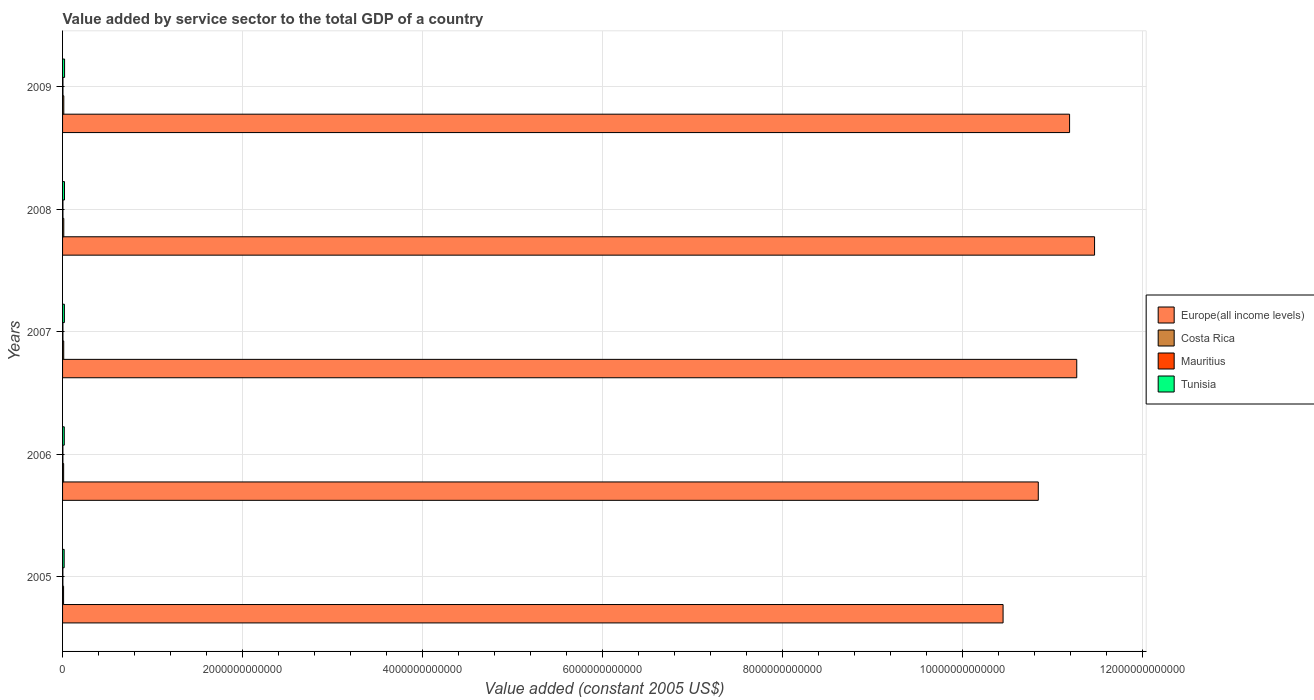How many different coloured bars are there?
Your response must be concise. 4. How many groups of bars are there?
Keep it short and to the point. 5. Are the number of bars per tick equal to the number of legend labels?
Your response must be concise. Yes. Are the number of bars on each tick of the Y-axis equal?
Offer a very short reply. Yes. How many bars are there on the 5th tick from the top?
Your answer should be compact. 4. In how many cases, is the number of bars for a given year not equal to the number of legend labels?
Give a very brief answer. 0. What is the value added by service sector in Tunisia in 2008?
Offer a terse response. 2.15e+1. Across all years, what is the maximum value added by service sector in Mauritius?
Provide a short and direct response. 4.46e+09. Across all years, what is the minimum value added by service sector in Mauritius?
Provide a short and direct response. 3.65e+09. What is the total value added by service sector in Mauritius in the graph?
Offer a very short reply. 2.04e+1. What is the difference between the value added by service sector in Tunisia in 2006 and that in 2009?
Offer a very short reply. -3.24e+09. What is the difference between the value added by service sector in Europe(all income levels) in 2009 and the value added by service sector in Costa Rica in 2007?
Offer a very short reply. 1.12e+13. What is the average value added by service sector in Tunisia per year?
Your response must be concise. 2.02e+1. In the year 2006, what is the difference between the value added by service sector in Europe(all income levels) and value added by service sector in Tunisia?
Ensure brevity in your answer.  1.08e+13. What is the ratio of the value added by service sector in Europe(all income levels) in 2007 to that in 2008?
Your answer should be very brief. 0.98. Is the value added by service sector in Europe(all income levels) in 2006 less than that in 2009?
Your response must be concise. Yes. Is the difference between the value added by service sector in Europe(all income levels) in 2005 and 2006 greater than the difference between the value added by service sector in Tunisia in 2005 and 2006?
Keep it short and to the point. No. What is the difference between the highest and the second highest value added by service sector in Tunisia?
Offer a terse response. 7.92e+08. What is the difference between the highest and the lowest value added by service sector in Costa Rica?
Keep it short and to the point. 2.53e+09. What does the 4th bar from the top in 2005 represents?
Ensure brevity in your answer.  Europe(all income levels). What does the 4th bar from the bottom in 2005 represents?
Provide a short and direct response. Tunisia. Is it the case that in every year, the sum of the value added by service sector in Europe(all income levels) and value added by service sector in Mauritius is greater than the value added by service sector in Costa Rica?
Provide a succinct answer. Yes. How many bars are there?
Your answer should be very brief. 20. Are all the bars in the graph horizontal?
Ensure brevity in your answer.  Yes. What is the difference between two consecutive major ticks on the X-axis?
Provide a succinct answer. 2.00e+12. Are the values on the major ticks of X-axis written in scientific E-notation?
Give a very brief answer. No. How many legend labels are there?
Offer a very short reply. 4. How are the legend labels stacked?
Offer a very short reply. Vertical. What is the title of the graph?
Provide a short and direct response. Value added by service sector to the total GDP of a country. Does "Ireland" appear as one of the legend labels in the graph?
Keep it short and to the point. No. What is the label or title of the X-axis?
Offer a very short reply. Value added (constant 2005 US$). What is the label or title of the Y-axis?
Give a very brief answer. Years. What is the Value added (constant 2005 US$) in Europe(all income levels) in 2005?
Your response must be concise. 1.05e+13. What is the Value added (constant 2005 US$) of Costa Rica in 2005?
Offer a very short reply. 1.12e+1. What is the Value added (constant 2005 US$) in Mauritius in 2005?
Your answer should be compact. 3.65e+09. What is the Value added (constant 2005 US$) of Tunisia in 2005?
Your answer should be very brief. 1.78e+1. What is the Value added (constant 2005 US$) of Europe(all income levels) in 2006?
Give a very brief answer. 1.08e+13. What is the Value added (constant 2005 US$) in Costa Rica in 2006?
Give a very brief answer. 1.19e+1. What is the Value added (constant 2005 US$) of Mauritius in 2006?
Give a very brief answer. 3.86e+09. What is the Value added (constant 2005 US$) of Tunisia in 2006?
Your response must be concise. 1.91e+1. What is the Value added (constant 2005 US$) in Europe(all income levels) in 2007?
Provide a short and direct response. 1.13e+13. What is the Value added (constant 2005 US$) of Costa Rica in 2007?
Make the answer very short. 1.28e+1. What is the Value added (constant 2005 US$) of Mauritius in 2007?
Provide a succinct answer. 4.11e+09. What is the Value added (constant 2005 US$) in Tunisia in 2007?
Provide a short and direct response. 2.02e+1. What is the Value added (constant 2005 US$) of Europe(all income levels) in 2008?
Provide a short and direct response. 1.15e+13. What is the Value added (constant 2005 US$) of Costa Rica in 2008?
Provide a succinct answer. 1.35e+1. What is the Value added (constant 2005 US$) in Mauritius in 2008?
Make the answer very short. 4.35e+09. What is the Value added (constant 2005 US$) in Tunisia in 2008?
Provide a short and direct response. 2.15e+1. What is the Value added (constant 2005 US$) of Europe(all income levels) in 2009?
Offer a terse response. 1.12e+13. What is the Value added (constant 2005 US$) of Costa Rica in 2009?
Your answer should be very brief. 1.37e+1. What is the Value added (constant 2005 US$) of Mauritius in 2009?
Provide a succinct answer. 4.46e+09. What is the Value added (constant 2005 US$) of Tunisia in 2009?
Your answer should be very brief. 2.23e+1. Across all years, what is the maximum Value added (constant 2005 US$) of Europe(all income levels)?
Provide a succinct answer. 1.15e+13. Across all years, what is the maximum Value added (constant 2005 US$) in Costa Rica?
Ensure brevity in your answer.  1.37e+1. Across all years, what is the maximum Value added (constant 2005 US$) of Mauritius?
Provide a short and direct response. 4.46e+09. Across all years, what is the maximum Value added (constant 2005 US$) of Tunisia?
Keep it short and to the point. 2.23e+1. Across all years, what is the minimum Value added (constant 2005 US$) of Europe(all income levels)?
Your response must be concise. 1.05e+13. Across all years, what is the minimum Value added (constant 2005 US$) of Costa Rica?
Provide a short and direct response. 1.12e+1. Across all years, what is the minimum Value added (constant 2005 US$) in Mauritius?
Your response must be concise. 3.65e+09. Across all years, what is the minimum Value added (constant 2005 US$) in Tunisia?
Your answer should be compact. 1.78e+1. What is the total Value added (constant 2005 US$) in Europe(all income levels) in the graph?
Provide a short and direct response. 5.52e+13. What is the total Value added (constant 2005 US$) in Costa Rica in the graph?
Provide a succinct answer. 6.31e+1. What is the total Value added (constant 2005 US$) in Mauritius in the graph?
Make the answer very short. 2.04e+1. What is the total Value added (constant 2005 US$) in Tunisia in the graph?
Your answer should be compact. 1.01e+11. What is the difference between the Value added (constant 2005 US$) of Europe(all income levels) in 2005 and that in 2006?
Offer a terse response. -3.91e+11. What is the difference between the Value added (constant 2005 US$) in Costa Rica in 2005 and that in 2006?
Your response must be concise. -7.75e+08. What is the difference between the Value added (constant 2005 US$) in Mauritius in 2005 and that in 2006?
Your answer should be compact. -2.06e+08. What is the difference between the Value added (constant 2005 US$) of Tunisia in 2005 and that in 2006?
Offer a very short reply. -1.29e+09. What is the difference between the Value added (constant 2005 US$) of Europe(all income levels) in 2005 and that in 2007?
Ensure brevity in your answer.  -8.19e+11. What is the difference between the Value added (constant 2005 US$) of Costa Rica in 2005 and that in 2007?
Your answer should be compact. -1.64e+09. What is the difference between the Value added (constant 2005 US$) in Mauritius in 2005 and that in 2007?
Your response must be concise. -4.61e+08. What is the difference between the Value added (constant 2005 US$) of Tunisia in 2005 and that in 2007?
Your answer should be compact. -2.45e+09. What is the difference between the Value added (constant 2005 US$) in Europe(all income levels) in 2005 and that in 2008?
Your answer should be very brief. -1.02e+12. What is the difference between the Value added (constant 2005 US$) of Costa Rica in 2005 and that in 2008?
Give a very brief answer. -2.38e+09. What is the difference between the Value added (constant 2005 US$) of Mauritius in 2005 and that in 2008?
Provide a short and direct response. -6.96e+08. What is the difference between the Value added (constant 2005 US$) of Tunisia in 2005 and that in 2008?
Your answer should be compact. -3.74e+09. What is the difference between the Value added (constant 2005 US$) of Europe(all income levels) in 2005 and that in 2009?
Your response must be concise. -7.39e+11. What is the difference between the Value added (constant 2005 US$) in Costa Rica in 2005 and that in 2009?
Your answer should be compact. -2.53e+09. What is the difference between the Value added (constant 2005 US$) of Mauritius in 2005 and that in 2009?
Provide a short and direct response. -8.15e+08. What is the difference between the Value added (constant 2005 US$) in Tunisia in 2005 and that in 2009?
Your response must be concise. -4.53e+09. What is the difference between the Value added (constant 2005 US$) in Europe(all income levels) in 2006 and that in 2007?
Keep it short and to the point. -4.27e+11. What is the difference between the Value added (constant 2005 US$) in Costa Rica in 2006 and that in 2007?
Keep it short and to the point. -8.64e+08. What is the difference between the Value added (constant 2005 US$) of Mauritius in 2006 and that in 2007?
Make the answer very short. -2.55e+08. What is the difference between the Value added (constant 2005 US$) of Tunisia in 2006 and that in 2007?
Ensure brevity in your answer.  -1.15e+09. What is the difference between the Value added (constant 2005 US$) of Europe(all income levels) in 2006 and that in 2008?
Provide a short and direct response. -6.25e+11. What is the difference between the Value added (constant 2005 US$) in Costa Rica in 2006 and that in 2008?
Offer a terse response. -1.60e+09. What is the difference between the Value added (constant 2005 US$) of Mauritius in 2006 and that in 2008?
Your answer should be very brief. -4.90e+08. What is the difference between the Value added (constant 2005 US$) in Tunisia in 2006 and that in 2008?
Keep it short and to the point. -2.45e+09. What is the difference between the Value added (constant 2005 US$) in Europe(all income levels) in 2006 and that in 2009?
Provide a succinct answer. -3.48e+11. What is the difference between the Value added (constant 2005 US$) in Costa Rica in 2006 and that in 2009?
Your response must be concise. -1.76e+09. What is the difference between the Value added (constant 2005 US$) of Mauritius in 2006 and that in 2009?
Your answer should be compact. -6.08e+08. What is the difference between the Value added (constant 2005 US$) of Tunisia in 2006 and that in 2009?
Your answer should be compact. -3.24e+09. What is the difference between the Value added (constant 2005 US$) in Europe(all income levels) in 2007 and that in 2008?
Offer a very short reply. -1.98e+11. What is the difference between the Value added (constant 2005 US$) of Costa Rica in 2007 and that in 2008?
Ensure brevity in your answer.  -7.38e+08. What is the difference between the Value added (constant 2005 US$) of Mauritius in 2007 and that in 2008?
Offer a very short reply. -2.35e+08. What is the difference between the Value added (constant 2005 US$) in Tunisia in 2007 and that in 2008?
Provide a short and direct response. -1.29e+09. What is the difference between the Value added (constant 2005 US$) of Europe(all income levels) in 2007 and that in 2009?
Keep it short and to the point. 7.96e+1. What is the difference between the Value added (constant 2005 US$) of Costa Rica in 2007 and that in 2009?
Offer a very short reply. -8.92e+08. What is the difference between the Value added (constant 2005 US$) of Mauritius in 2007 and that in 2009?
Keep it short and to the point. -3.53e+08. What is the difference between the Value added (constant 2005 US$) in Tunisia in 2007 and that in 2009?
Give a very brief answer. -2.09e+09. What is the difference between the Value added (constant 2005 US$) of Europe(all income levels) in 2008 and that in 2009?
Your answer should be compact. 2.78e+11. What is the difference between the Value added (constant 2005 US$) in Costa Rica in 2008 and that in 2009?
Offer a terse response. -1.53e+08. What is the difference between the Value added (constant 2005 US$) of Mauritius in 2008 and that in 2009?
Keep it short and to the point. -1.18e+08. What is the difference between the Value added (constant 2005 US$) of Tunisia in 2008 and that in 2009?
Your response must be concise. -7.92e+08. What is the difference between the Value added (constant 2005 US$) in Europe(all income levels) in 2005 and the Value added (constant 2005 US$) in Costa Rica in 2006?
Make the answer very short. 1.04e+13. What is the difference between the Value added (constant 2005 US$) of Europe(all income levels) in 2005 and the Value added (constant 2005 US$) of Mauritius in 2006?
Offer a terse response. 1.04e+13. What is the difference between the Value added (constant 2005 US$) of Europe(all income levels) in 2005 and the Value added (constant 2005 US$) of Tunisia in 2006?
Keep it short and to the point. 1.04e+13. What is the difference between the Value added (constant 2005 US$) in Costa Rica in 2005 and the Value added (constant 2005 US$) in Mauritius in 2006?
Your answer should be compact. 7.31e+09. What is the difference between the Value added (constant 2005 US$) of Costa Rica in 2005 and the Value added (constant 2005 US$) of Tunisia in 2006?
Provide a short and direct response. -7.89e+09. What is the difference between the Value added (constant 2005 US$) in Mauritius in 2005 and the Value added (constant 2005 US$) in Tunisia in 2006?
Your response must be concise. -1.54e+1. What is the difference between the Value added (constant 2005 US$) of Europe(all income levels) in 2005 and the Value added (constant 2005 US$) of Costa Rica in 2007?
Make the answer very short. 1.04e+13. What is the difference between the Value added (constant 2005 US$) in Europe(all income levels) in 2005 and the Value added (constant 2005 US$) in Mauritius in 2007?
Your answer should be very brief. 1.04e+13. What is the difference between the Value added (constant 2005 US$) in Europe(all income levels) in 2005 and the Value added (constant 2005 US$) in Tunisia in 2007?
Keep it short and to the point. 1.04e+13. What is the difference between the Value added (constant 2005 US$) of Costa Rica in 2005 and the Value added (constant 2005 US$) of Mauritius in 2007?
Your answer should be very brief. 7.05e+09. What is the difference between the Value added (constant 2005 US$) of Costa Rica in 2005 and the Value added (constant 2005 US$) of Tunisia in 2007?
Offer a very short reply. -9.04e+09. What is the difference between the Value added (constant 2005 US$) in Mauritius in 2005 and the Value added (constant 2005 US$) in Tunisia in 2007?
Your response must be concise. -1.66e+1. What is the difference between the Value added (constant 2005 US$) in Europe(all income levels) in 2005 and the Value added (constant 2005 US$) in Costa Rica in 2008?
Your response must be concise. 1.04e+13. What is the difference between the Value added (constant 2005 US$) in Europe(all income levels) in 2005 and the Value added (constant 2005 US$) in Mauritius in 2008?
Provide a short and direct response. 1.04e+13. What is the difference between the Value added (constant 2005 US$) in Europe(all income levels) in 2005 and the Value added (constant 2005 US$) in Tunisia in 2008?
Offer a terse response. 1.04e+13. What is the difference between the Value added (constant 2005 US$) of Costa Rica in 2005 and the Value added (constant 2005 US$) of Mauritius in 2008?
Keep it short and to the point. 6.82e+09. What is the difference between the Value added (constant 2005 US$) in Costa Rica in 2005 and the Value added (constant 2005 US$) in Tunisia in 2008?
Your response must be concise. -1.03e+1. What is the difference between the Value added (constant 2005 US$) in Mauritius in 2005 and the Value added (constant 2005 US$) in Tunisia in 2008?
Provide a succinct answer. -1.79e+1. What is the difference between the Value added (constant 2005 US$) of Europe(all income levels) in 2005 and the Value added (constant 2005 US$) of Costa Rica in 2009?
Provide a succinct answer. 1.04e+13. What is the difference between the Value added (constant 2005 US$) of Europe(all income levels) in 2005 and the Value added (constant 2005 US$) of Mauritius in 2009?
Provide a succinct answer. 1.04e+13. What is the difference between the Value added (constant 2005 US$) of Europe(all income levels) in 2005 and the Value added (constant 2005 US$) of Tunisia in 2009?
Offer a very short reply. 1.04e+13. What is the difference between the Value added (constant 2005 US$) in Costa Rica in 2005 and the Value added (constant 2005 US$) in Mauritius in 2009?
Give a very brief answer. 6.70e+09. What is the difference between the Value added (constant 2005 US$) in Costa Rica in 2005 and the Value added (constant 2005 US$) in Tunisia in 2009?
Your answer should be compact. -1.11e+1. What is the difference between the Value added (constant 2005 US$) in Mauritius in 2005 and the Value added (constant 2005 US$) in Tunisia in 2009?
Give a very brief answer. -1.86e+1. What is the difference between the Value added (constant 2005 US$) in Europe(all income levels) in 2006 and the Value added (constant 2005 US$) in Costa Rica in 2007?
Offer a very short reply. 1.08e+13. What is the difference between the Value added (constant 2005 US$) of Europe(all income levels) in 2006 and the Value added (constant 2005 US$) of Mauritius in 2007?
Ensure brevity in your answer.  1.08e+13. What is the difference between the Value added (constant 2005 US$) in Europe(all income levels) in 2006 and the Value added (constant 2005 US$) in Tunisia in 2007?
Offer a terse response. 1.08e+13. What is the difference between the Value added (constant 2005 US$) of Costa Rica in 2006 and the Value added (constant 2005 US$) of Mauritius in 2007?
Provide a short and direct response. 7.83e+09. What is the difference between the Value added (constant 2005 US$) in Costa Rica in 2006 and the Value added (constant 2005 US$) in Tunisia in 2007?
Your answer should be very brief. -8.27e+09. What is the difference between the Value added (constant 2005 US$) of Mauritius in 2006 and the Value added (constant 2005 US$) of Tunisia in 2007?
Provide a short and direct response. -1.64e+1. What is the difference between the Value added (constant 2005 US$) in Europe(all income levels) in 2006 and the Value added (constant 2005 US$) in Costa Rica in 2008?
Your response must be concise. 1.08e+13. What is the difference between the Value added (constant 2005 US$) in Europe(all income levels) in 2006 and the Value added (constant 2005 US$) in Mauritius in 2008?
Keep it short and to the point. 1.08e+13. What is the difference between the Value added (constant 2005 US$) in Europe(all income levels) in 2006 and the Value added (constant 2005 US$) in Tunisia in 2008?
Provide a succinct answer. 1.08e+13. What is the difference between the Value added (constant 2005 US$) in Costa Rica in 2006 and the Value added (constant 2005 US$) in Mauritius in 2008?
Provide a succinct answer. 7.59e+09. What is the difference between the Value added (constant 2005 US$) in Costa Rica in 2006 and the Value added (constant 2005 US$) in Tunisia in 2008?
Give a very brief answer. -9.56e+09. What is the difference between the Value added (constant 2005 US$) in Mauritius in 2006 and the Value added (constant 2005 US$) in Tunisia in 2008?
Your answer should be compact. -1.76e+1. What is the difference between the Value added (constant 2005 US$) of Europe(all income levels) in 2006 and the Value added (constant 2005 US$) of Costa Rica in 2009?
Ensure brevity in your answer.  1.08e+13. What is the difference between the Value added (constant 2005 US$) in Europe(all income levels) in 2006 and the Value added (constant 2005 US$) in Mauritius in 2009?
Make the answer very short. 1.08e+13. What is the difference between the Value added (constant 2005 US$) in Europe(all income levels) in 2006 and the Value added (constant 2005 US$) in Tunisia in 2009?
Provide a short and direct response. 1.08e+13. What is the difference between the Value added (constant 2005 US$) of Costa Rica in 2006 and the Value added (constant 2005 US$) of Mauritius in 2009?
Provide a short and direct response. 7.48e+09. What is the difference between the Value added (constant 2005 US$) of Costa Rica in 2006 and the Value added (constant 2005 US$) of Tunisia in 2009?
Ensure brevity in your answer.  -1.04e+1. What is the difference between the Value added (constant 2005 US$) of Mauritius in 2006 and the Value added (constant 2005 US$) of Tunisia in 2009?
Your answer should be compact. -1.84e+1. What is the difference between the Value added (constant 2005 US$) of Europe(all income levels) in 2007 and the Value added (constant 2005 US$) of Costa Rica in 2008?
Provide a short and direct response. 1.13e+13. What is the difference between the Value added (constant 2005 US$) of Europe(all income levels) in 2007 and the Value added (constant 2005 US$) of Mauritius in 2008?
Your answer should be compact. 1.13e+13. What is the difference between the Value added (constant 2005 US$) of Europe(all income levels) in 2007 and the Value added (constant 2005 US$) of Tunisia in 2008?
Offer a terse response. 1.12e+13. What is the difference between the Value added (constant 2005 US$) of Costa Rica in 2007 and the Value added (constant 2005 US$) of Mauritius in 2008?
Make the answer very short. 8.46e+09. What is the difference between the Value added (constant 2005 US$) in Costa Rica in 2007 and the Value added (constant 2005 US$) in Tunisia in 2008?
Give a very brief answer. -8.70e+09. What is the difference between the Value added (constant 2005 US$) of Mauritius in 2007 and the Value added (constant 2005 US$) of Tunisia in 2008?
Offer a very short reply. -1.74e+1. What is the difference between the Value added (constant 2005 US$) in Europe(all income levels) in 2007 and the Value added (constant 2005 US$) in Costa Rica in 2009?
Ensure brevity in your answer.  1.13e+13. What is the difference between the Value added (constant 2005 US$) of Europe(all income levels) in 2007 and the Value added (constant 2005 US$) of Mauritius in 2009?
Make the answer very short. 1.13e+13. What is the difference between the Value added (constant 2005 US$) of Europe(all income levels) in 2007 and the Value added (constant 2005 US$) of Tunisia in 2009?
Keep it short and to the point. 1.12e+13. What is the difference between the Value added (constant 2005 US$) of Costa Rica in 2007 and the Value added (constant 2005 US$) of Mauritius in 2009?
Provide a short and direct response. 8.34e+09. What is the difference between the Value added (constant 2005 US$) in Costa Rica in 2007 and the Value added (constant 2005 US$) in Tunisia in 2009?
Make the answer very short. -9.49e+09. What is the difference between the Value added (constant 2005 US$) in Mauritius in 2007 and the Value added (constant 2005 US$) in Tunisia in 2009?
Give a very brief answer. -1.82e+1. What is the difference between the Value added (constant 2005 US$) in Europe(all income levels) in 2008 and the Value added (constant 2005 US$) in Costa Rica in 2009?
Your response must be concise. 1.15e+13. What is the difference between the Value added (constant 2005 US$) of Europe(all income levels) in 2008 and the Value added (constant 2005 US$) of Mauritius in 2009?
Offer a terse response. 1.15e+13. What is the difference between the Value added (constant 2005 US$) in Europe(all income levels) in 2008 and the Value added (constant 2005 US$) in Tunisia in 2009?
Your answer should be compact. 1.14e+13. What is the difference between the Value added (constant 2005 US$) of Costa Rica in 2008 and the Value added (constant 2005 US$) of Mauritius in 2009?
Your answer should be very brief. 9.08e+09. What is the difference between the Value added (constant 2005 US$) of Costa Rica in 2008 and the Value added (constant 2005 US$) of Tunisia in 2009?
Your answer should be compact. -8.75e+09. What is the difference between the Value added (constant 2005 US$) in Mauritius in 2008 and the Value added (constant 2005 US$) in Tunisia in 2009?
Your answer should be compact. -1.79e+1. What is the average Value added (constant 2005 US$) in Europe(all income levels) per year?
Keep it short and to the point. 1.10e+13. What is the average Value added (constant 2005 US$) of Costa Rica per year?
Provide a short and direct response. 1.26e+1. What is the average Value added (constant 2005 US$) of Mauritius per year?
Offer a very short reply. 4.09e+09. What is the average Value added (constant 2005 US$) in Tunisia per year?
Provide a short and direct response. 2.02e+1. In the year 2005, what is the difference between the Value added (constant 2005 US$) in Europe(all income levels) and Value added (constant 2005 US$) in Costa Rica?
Keep it short and to the point. 1.04e+13. In the year 2005, what is the difference between the Value added (constant 2005 US$) of Europe(all income levels) and Value added (constant 2005 US$) of Mauritius?
Ensure brevity in your answer.  1.04e+13. In the year 2005, what is the difference between the Value added (constant 2005 US$) of Europe(all income levels) and Value added (constant 2005 US$) of Tunisia?
Your response must be concise. 1.04e+13. In the year 2005, what is the difference between the Value added (constant 2005 US$) of Costa Rica and Value added (constant 2005 US$) of Mauritius?
Provide a short and direct response. 7.51e+09. In the year 2005, what is the difference between the Value added (constant 2005 US$) of Costa Rica and Value added (constant 2005 US$) of Tunisia?
Your answer should be compact. -6.60e+09. In the year 2005, what is the difference between the Value added (constant 2005 US$) in Mauritius and Value added (constant 2005 US$) in Tunisia?
Give a very brief answer. -1.41e+1. In the year 2006, what is the difference between the Value added (constant 2005 US$) of Europe(all income levels) and Value added (constant 2005 US$) of Costa Rica?
Provide a succinct answer. 1.08e+13. In the year 2006, what is the difference between the Value added (constant 2005 US$) in Europe(all income levels) and Value added (constant 2005 US$) in Mauritius?
Ensure brevity in your answer.  1.08e+13. In the year 2006, what is the difference between the Value added (constant 2005 US$) of Europe(all income levels) and Value added (constant 2005 US$) of Tunisia?
Make the answer very short. 1.08e+13. In the year 2006, what is the difference between the Value added (constant 2005 US$) of Costa Rica and Value added (constant 2005 US$) of Mauritius?
Offer a very short reply. 8.08e+09. In the year 2006, what is the difference between the Value added (constant 2005 US$) of Costa Rica and Value added (constant 2005 US$) of Tunisia?
Offer a very short reply. -7.11e+09. In the year 2006, what is the difference between the Value added (constant 2005 US$) in Mauritius and Value added (constant 2005 US$) in Tunisia?
Offer a terse response. -1.52e+1. In the year 2007, what is the difference between the Value added (constant 2005 US$) of Europe(all income levels) and Value added (constant 2005 US$) of Costa Rica?
Your response must be concise. 1.13e+13. In the year 2007, what is the difference between the Value added (constant 2005 US$) of Europe(all income levels) and Value added (constant 2005 US$) of Mauritius?
Ensure brevity in your answer.  1.13e+13. In the year 2007, what is the difference between the Value added (constant 2005 US$) in Europe(all income levels) and Value added (constant 2005 US$) in Tunisia?
Your answer should be compact. 1.13e+13. In the year 2007, what is the difference between the Value added (constant 2005 US$) in Costa Rica and Value added (constant 2005 US$) in Mauritius?
Offer a terse response. 8.69e+09. In the year 2007, what is the difference between the Value added (constant 2005 US$) of Costa Rica and Value added (constant 2005 US$) of Tunisia?
Ensure brevity in your answer.  -7.40e+09. In the year 2007, what is the difference between the Value added (constant 2005 US$) of Mauritius and Value added (constant 2005 US$) of Tunisia?
Offer a very short reply. -1.61e+1. In the year 2008, what is the difference between the Value added (constant 2005 US$) of Europe(all income levels) and Value added (constant 2005 US$) of Costa Rica?
Give a very brief answer. 1.15e+13. In the year 2008, what is the difference between the Value added (constant 2005 US$) in Europe(all income levels) and Value added (constant 2005 US$) in Mauritius?
Make the answer very short. 1.15e+13. In the year 2008, what is the difference between the Value added (constant 2005 US$) in Europe(all income levels) and Value added (constant 2005 US$) in Tunisia?
Give a very brief answer. 1.14e+13. In the year 2008, what is the difference between the Value added (constant 2005 US$) in Costa Rica and Value added (constant 2005 US$) in Mauritius?
Keep it short and to the point. 9.20e+09. In the year 2008, what is the difference between the Value added (constant 2005 US$) in Costa Rica and Value added (constant 2005 US$) in Tunisia?
Ensure brevity in your answer.  -7.96e+09. In the year 2008, what is the difference between the Value added (constant 2005 US$) in Mauritius and Value added (constant 2005 US$) in Tunisia?
Ensure brevity in your answer.  -1.72e+1. In the year 2009, what is the difference between the Value added (constant 2005 US$) of Europe(all income levels) and Value added (constant 2005 US$) of Costa Rica?
Keep it short and to the point. 1.12e+13. In the year 2009, what is the difference between the Value added (constant 2005 US$) of Europe(all income levels) and Value added (constant 2005 US$) of Mauritius?
Offer a very short reply. 1.12e+13. In the year 2009, what is the difference between the Value added (constant 2005 US$) in Europe(all income levels) and Value added (constant 2005 US$) in Tunisia?
Give a very brief answer. 1.12e+13. In the year 2009, what is the difference between the Value added (constant 2005 US$) in Costa Rica and Value added (constant 2005 US$) in Mauritius?
Offer a very short reply. 9.23e+09. In the year 2009, what is the difference between the Value added (constant 2005 US$) in Costa Rica and Value added (constant 2005 US$) in Tunisia?
Make the answer very short. -8.60e+09. In the year 2009, what is the difference between the Value added (constant 2005 US$) in Mauritius and Value added (constant 2005 US$) in Tunisia?
Offer a terse response. -1.78e+1. What is the ratio of the Value added (constant 2005 US$) in Europe(all income levels) in 2005 to that in 2006?
Ensure brevity in your answer.  0.96. What is the ratio of the Value added (constant 2005 US$) in Costa Rica in 2005 to that in 2006?
Your response must be concise. 0.94. What is the ratio of the Value added (constant 2005 US$) in Mauritius in 2005 to that in 2006?
Your answer should be compact. 0.95. What is the ratio of the Value added (constant 2005 US$) of Tunisia in 2005 to that in 2006?
Provide a short and direct response. 0.93. What is the ratio of the Value added (constant 2005 US$) of Europe(all income levels) in 2005 to that in 2007?
Provide a succinct answer. 0.93. What is the ratio of the Value added (constant 2005 US$) in Costa Rica in 2005 to that in 2007?
Provide a short and direct response. 0.87. What is the ratio of the Value added (constant 2005 US$) of Mauritius in 2005 to that in 2007?
Give a very brief answer. 0.89. What is the ratio of the Value added (constant 2005 US$) in Tunisia in 2005 to that in 2007?
Provide a succinct answer. 0.88. What is the ratio of the Value added (constant 2005 US$) in Europe(all income levels) in 2005 to that in 2008?
Make the answer very short. 0.91. What is the ratio of the Value added (constant 2005 US$) in Costa Rica in 2005 to that in 2008?
Provide a short and direct response. 0.82. What is the ratio of the Value added (constant 2005 US$) in Mauritius in 2005 to that in 2008?
Ensure brevity in your answer.  0.84. What is the ratio of the Value added (constant 2005 US$) in Tunisia in 2005 to that in 2008?
Ensure brevity in your answer.  0.83. What is the ratio of the Value added (constant 2005 US$) of Europe(all income levels) in 2005 to that in 2009?
Your answer should be compact. 0.93. What is the ratio of the Value added (constant 2005 US$) of Costa Rica in 2005 to that in 2009?
Make the answer very short. 0.82. What is the ratio of the Value added (constant 2005 US$) in Mauritius in 2005 to that in 2009?
Make the answer very short. 0.82. What is the ratio of the Value added (constant 2005 US$) of Tunisia in 2005 to that in 2009?
Offer a terse response. 0.8. What is the ratio of the Value added (constant 2005 US$) in Europe(all income levels) in 2006 to that in 2007?
Your answer should be compact. 0.96. What is the ratio of the Value added (constant 2005 US$) of Costa Rica in 2006 to that in 2007?
Provide a succinct answer. 0.93. What is the ratio of the Value added (constant 2005 US$) of Mauritius in 2006 to that in 2007?
Make the answer very short. 0.94. What is the ratio of the Value added (constant 2005 US$) in Tunisia in 2006 to that in 2007?
Keep it short and to the point. 0.94. What is the ratio of the Value added (constant 2005 US$) in Europe(all income levels) in 2006 to that in 2008?
Your answer should be very brief. 0.95. What is the ratio of the Value added (constant 2005 US$) of Costa Rica in 2006 to that in 2008?
Ensure brevity in your answer.  0.88. What is the ratio of the Value added (constant 2005 US$) of Mauritius in 2006 to that in 2008?
Give a very brief answer. 0.89. What is the ratio of the Value added (constant 2005 US$) in Tunisia in 2006 to that in 2008?
Your answer should be very brief. 0.89. What is the ratio of the Value added (constant 2005 US$) of Europe(all income levels) in 2006 to that in 2009?
Your answer should be compact. 0.97. What is the ratio of the Value added (constant 2005 US$) in Costa Rica in 2006 to that in 2009?
Your response must be concise. 0.87. What is the ratio of the Value added (constant 2005 US$) in Mauritius in 2006 to that in 2009?
Give a very brief answer. 0.86. What is the ratio of the Value added (constant 2005 US$) of Tunisia in 2006 to that in 2009?
Your answer should be compact. 0.85. What is the ratio of the Value added (constant 2005 US$) of Europe(all income levels) in 2007 to that in 2008?
Offer a very short reply. 0.98. What is the ratio of the Value added (constant 2005 US$) in Costa Rica in 2007 to that in 2008?
Your response must be concise. 0.95. What is the ratio of the Value added (constant 2005 US$) in Mauritius in 2007 to that in 2008?
Provide a succinct answer. 0.95. What is the ratio of the Value added (constant 2005 US$) in Tunisia in 2007 to that in 2008?
Make the answer very short. 0.94. What is the ratio of the Value added (constant 2005 US$) of Europe(all income levels) in 2007 to that in 2009?
Your answer should be very brief. 1.01. What is the ratio of the Value added (constant 2005 US$) of Costa Rica in 2007 to that in 2009?
Offer a terse response. 0.93. What is the ratio of the Value added (constant 2005 US$) of Mauritius in 2007 to that in 2009?
Offer a terse response. 0.92. What is the ratio of the Value added (constant 2005 US$) in Tunisia in 2007 to that in 2009?
Provide a short and direct response. 0.91. What is the ratio of the Value added (constant 2005 US$) in Europe(all income levels) in 2008 to that in 2009?
Make the answer very short. 1.02. What is the ratio of the Value added (constant 2005 US$) of Mauritius in 2008 to that in 2009?
Provide a succinct answer. 0.97. What is the ratio of the Value added (constant 2005 US$) of Tunisia in 2008 to that in 2009?
Your answer should be compact. 0.96. What is the difference between the highest and the second highest Value added (constant 2005 US$) in Europe(all income levels)?
Provide a succinct answer. 1.98e+11. What is the difference between the highest and the second highest Value added (constant 2005 US$) in Costa Rica?
Make the answer very short. 1.53e+08. What is the difference between the highest and the second highest Value added (constant 2005 US$) of Mauritius?
Make the answer very short. 1.18e+08. What is the difference between the highest and the second highest Value added (constant 2005 US$) in Tunisia?
Provide a short and direct response. 7.92e+08. What is the difference between the highest and the lowest Value added (constant 2005 US$) of Europe(all income levels)?
Provide a short and direct response. 1.02e+12. What is the difference between the highest and the lowest Value added (constant 2005 US$) in Costa Rica?
Give a very brief answer. 2.53e+09. What is the difference between the highest and the lowest Value added (constant 2005 US$) in Mauritius?
Give a very brief answer. 8.15e+08. What is the difference between the highest and the lowest Value added (constant 2005 US$) in Tunisia?
Provide a short and direct response. 4.53e+09. 